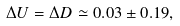Convert formula to latex. <formula><loc_0><loc_0><loc_500><loc_500>\Delta U = \Delta D \simeq 0 . 0 3 \pm 0 . 1 9 ,</formula> 